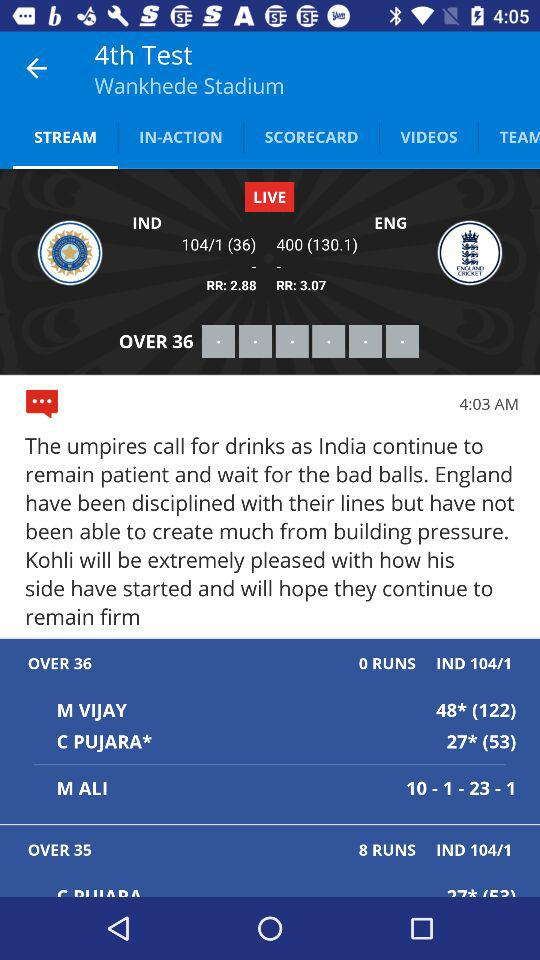What is the name of the stadium? The name of the stadium is "Wankhede Stadium". 